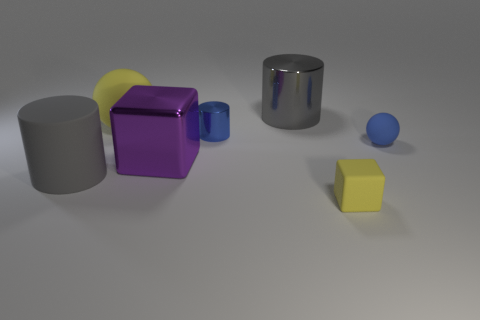Add 1 small matte spheres. How many objects exist? 8 Subtract all balls. How many objects are left? 5 Add 6 tiny cylinders. How many tiny cylinders are left? 7 Add 3 rubber spheres. How many rubber spheres exist? 5 Subtract 0 cyan blocks. How many objects are left? 7 Subtract all blue spheres. Subtract all small yellow matte objects. How many objects are left? 5 